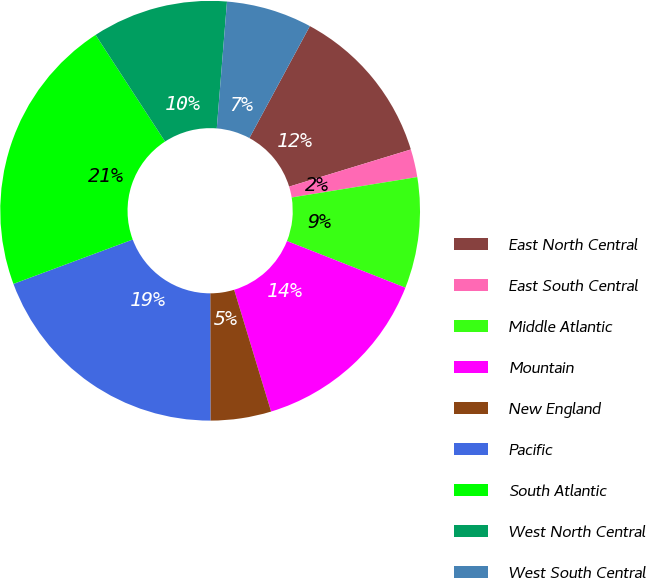<chart> <loc_0><loc_0><loc_500><loc_500><pie_chart><fcel>East North Central<fcel>East South Central<fcel>Middle Atlantic<fcel>Mountain<fcel>New England<fcel>Pacific<fcel>South Atlantic<fcel>West North Central<fcel>West South Central<nl><fcel>12.4%<fcel>2.15%<fcel>8.54%<fcel>14.33%<fcel>4.67%<fcel>19.35%<fcel>21.47%<fcel>10.47%<fcel>6.6%<nl></chart> 